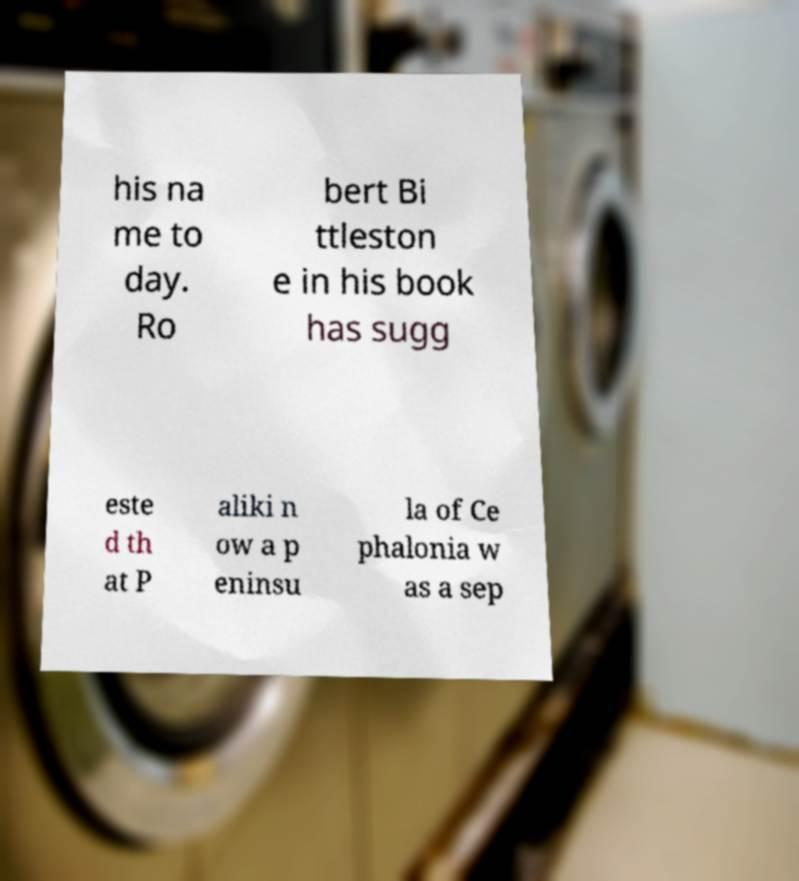I need the written content from this picture converted into text. Can you do that? his na me to day. Ro bert Bi ttleston e in his book has sugg este d th at P aliki n ow a p eninsu la of Ce phalonia w as a sep 